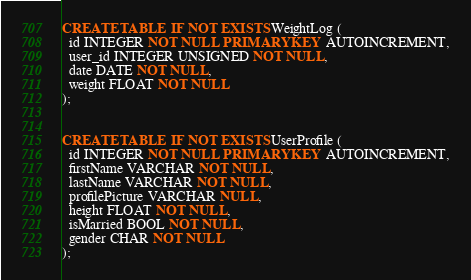Convert code to text. <code><loc_0><loc_0><loc_500><loc_500><_SQL_>
CREATE TABLE  IF NOT EXISTS WeightLog (
  id INTEGER NOT NULL PRIMARY KEY  AUTOINCREMENT,
  user_id INTEGER UNSIGNED NOT NULL,
  date DATE NOT NULL,
  weight FLOAT NOT NULL
);


CREATE TABLE  IF NOT EXISTS UserProfile (
  id INTEGER NOT NULL PRIMARY KEY  AUTOINCREMENT,
  firstName VARCHAR NOT NULL,
  lastName VARCHAR NOT NULL,
  profilePicture VARCHAR NULL,
  height FLOAT NOT NULL,
  isMarried BOOL NOT NULL,
  gender CHAR NOT NULL
);</code> 